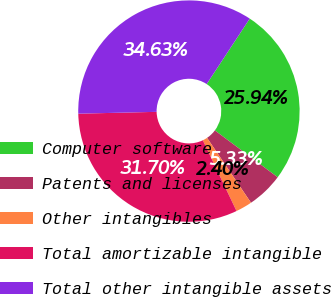<chart> <loc_0><loc_0><loc_500><loc_500><pie_chart><fcel>Computer software<fcel>Patents and licenses<fcel>Other intangibles<fcel>Total amortizable intangible<fcel>Total other intangible assets<nl><fcel>25.94%<fcel>5.33%<fcel>2.4%<fcel>31.7%<fcel>34.63%<nl></chart> 